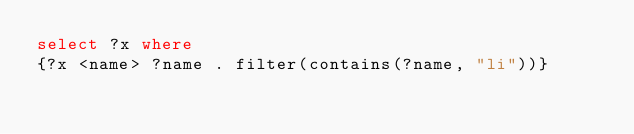<code> <loc_0><loc_0><loc_500><loc_500><_SQL_>select ?x where
{?x <name> ?name . filter(contains(?name, "li"))}</code> 